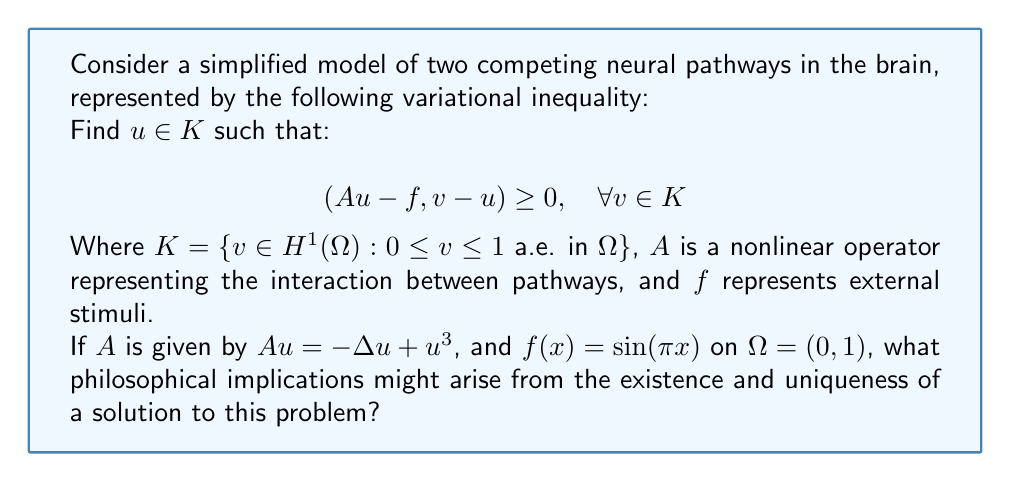Could you help me with this problem? To understand the philosophical implications, let's break down the problem and its solution:

1. The variational inequality represents a competition between two neural pathways, where:
   - $u$ represents the activation level of the dominant pathway
   - $v$ represents potential alternative activation patterns
   - $K$ constrains the activation levels between 0 and 1

2. The operator $A$ models the interaction:
   - $-\Delta u$ represents diffusion of activation
   - $u^3$ represents a nonlinear self-reinforcement effect

3. $f(x) = \sin(\pi x)$ represents external stimuli varying across the domain

4. The existence and uniqueness of a solution can be proven using the theory of monotone operators and the properties of the space $H^1(\Omega)$.

5. Philosophical implications:

   a) Determinism vs. Free Will: The existence of a unique solution suggests a deterministic view of neural processes. Given specific stimuli and pathway interactions, there's only one possible outcome.

   b) Emergence of Consciousness: The nonlinear term $u^3$ implies that small changes in initial conditions can lead to significant differences in outcomes, potentially relating to the emergence of conscious experiences from neural activity.

   c) Limits of Reductionism: While we can model complex neural interactions mathematically, the simplifications required (e.g., representing pathways with a single function) highlight the limitations of reductive approaches in understanding consciousness.

   d) Mind-Body Problem: The model bridges physical processes (neural activation) with abstract mathematical concepts, potentially informing discussions on the relationship between physical brain states and mental phenomena.

   e) Epistemological Boundaries: The complexity of the model, despite its simplifications, underscores the challenges in fully understanding and predicting brain function, raising questions about the limits of human knowledge in neuroscience.
Answer: The existence and uniqueness of a solution implies deterministic neural processes, challenges reductionist approaches, informs the mind-body problem, and highlights epistemological limitations in neuroscience. 